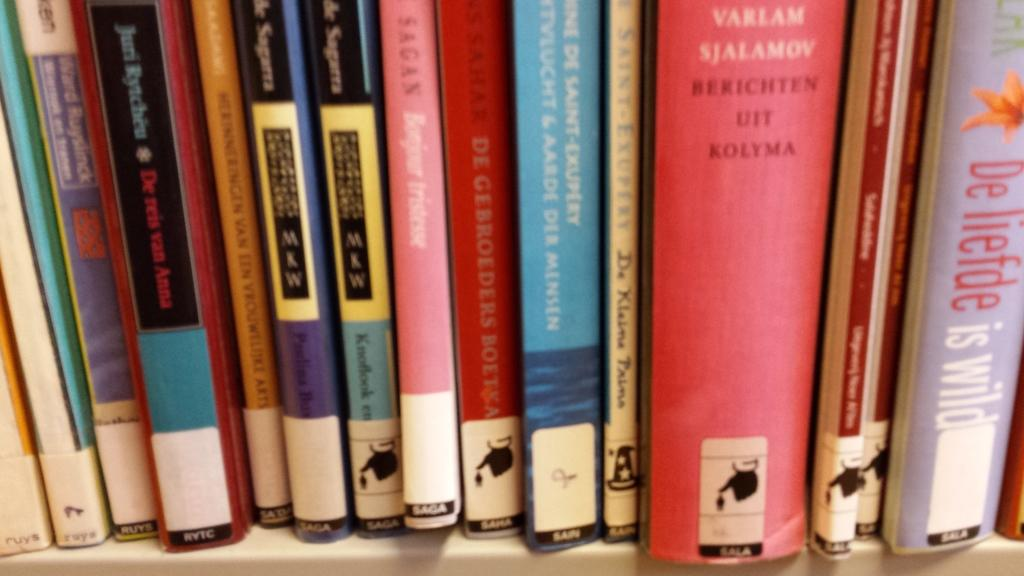<image>
Write a terse but informative summary of the picture. a shelve of books with one of them titled 'varlam sjalamoy' 